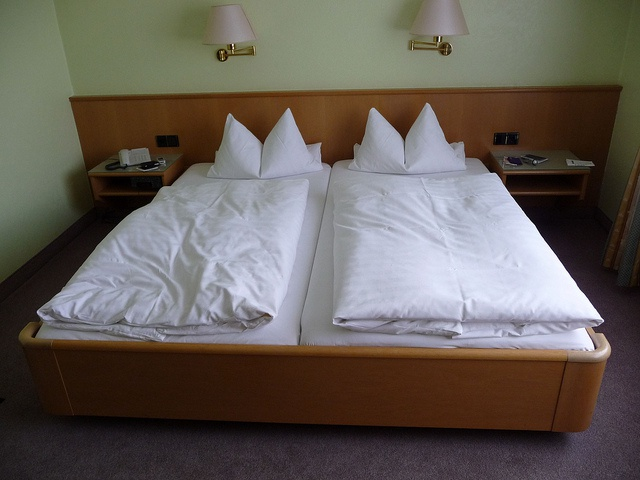Describe the objects in this image and their specific colors. I can see a bed in darkgreen, darkgray, maroon, black, and lavender tones in this image. 